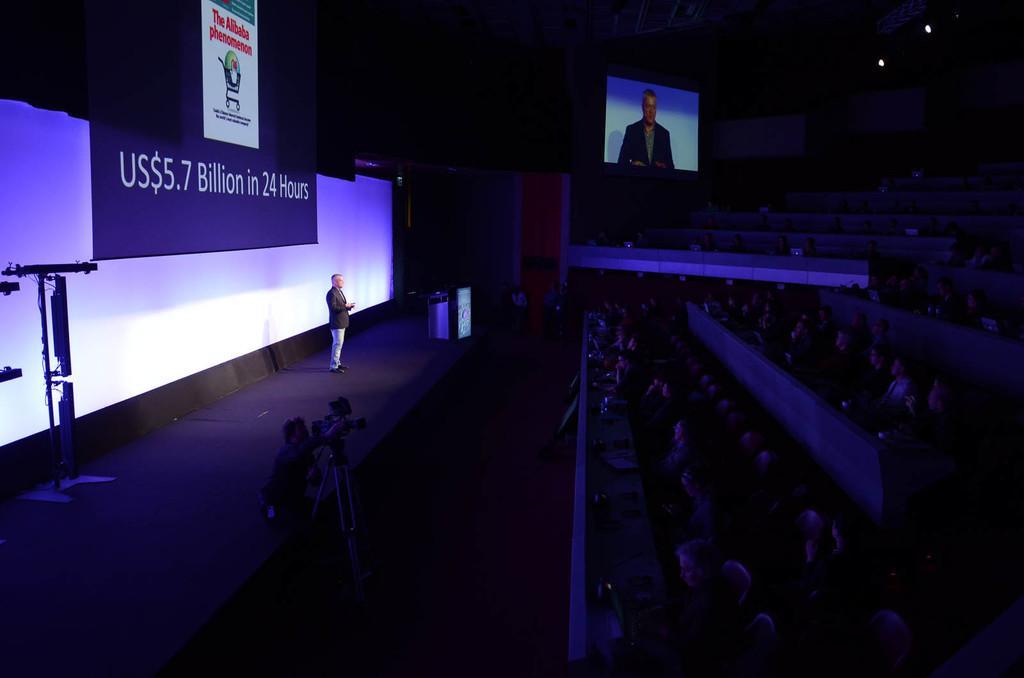How would you summarize this image in a sentence or two? This picture describe about the photo of the auditorium. In front we can see a man wearing black coat and blue jeans standing on the stage and giving speech. Behind you can see a projector screen and camera man on the stage. On the right side we can see many people as audience sitting and listening to him. 